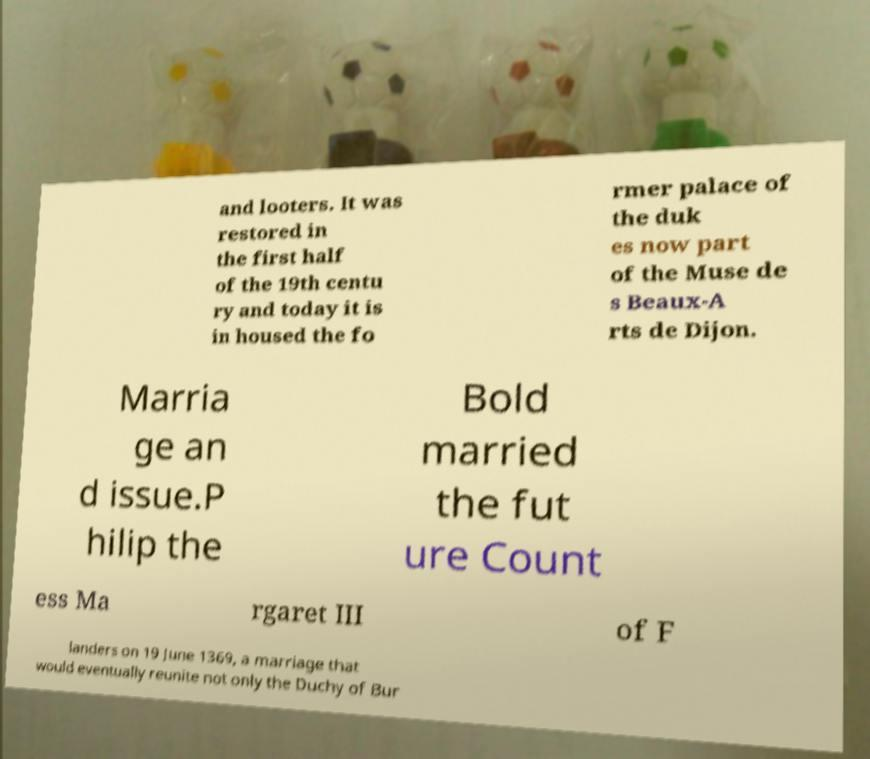I need the written content from this picture converted into text. Can you do that? and looters. It was restored in the first half of the 19th centu ry and today it is in housed the fo rmer palace of the duk es now part of the Muse de s Beaux-A rts de Dijon. Marria ge an d issue.P hilip the Bold married the fut ure Count ess Ma rgaret III of F landers on 19 June 1369, a marriage that would eventually reunite not only the Duchy of Bur 